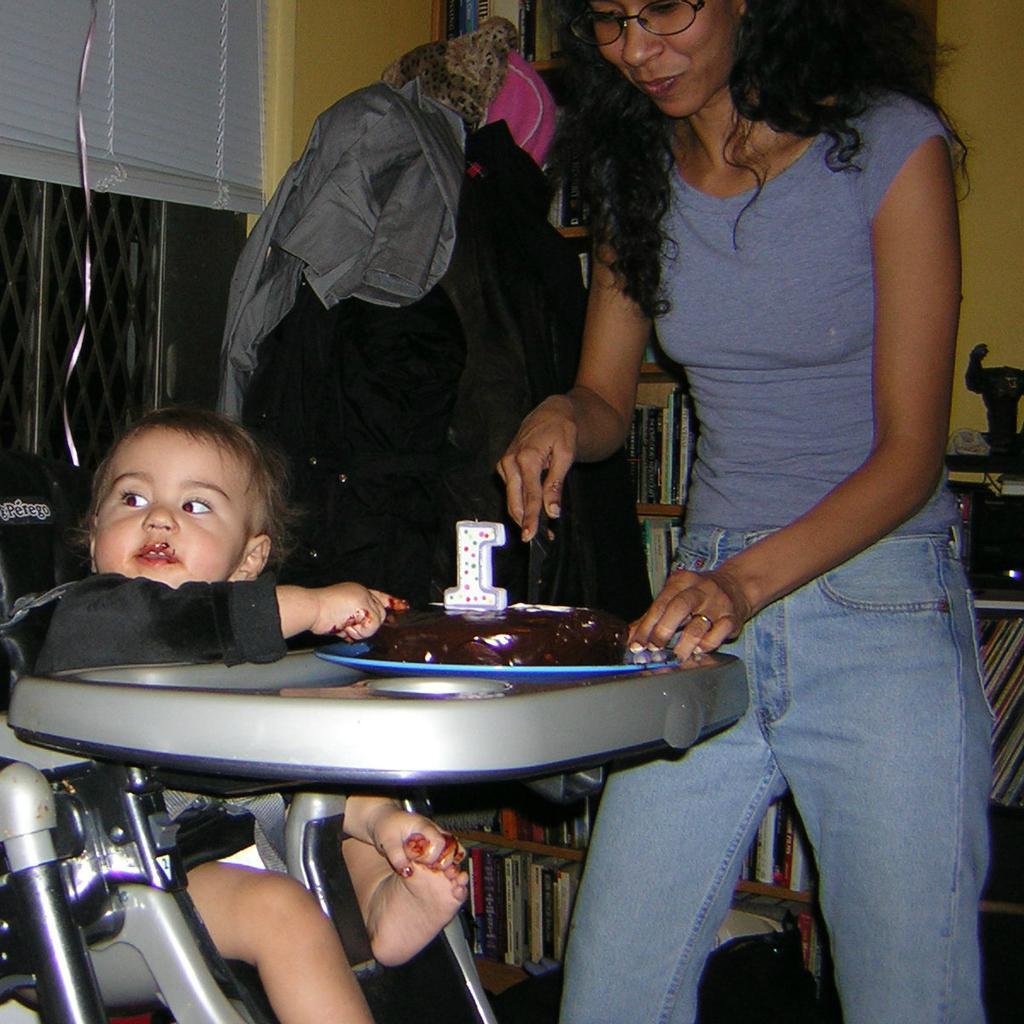Can you describe this image briefly? In the image we can see a baby standing, wearing clothes, finger ring, spectacles and holding a knife in hand, and here we can see a baby. Here we can see cake, books, wall and window blinds. 